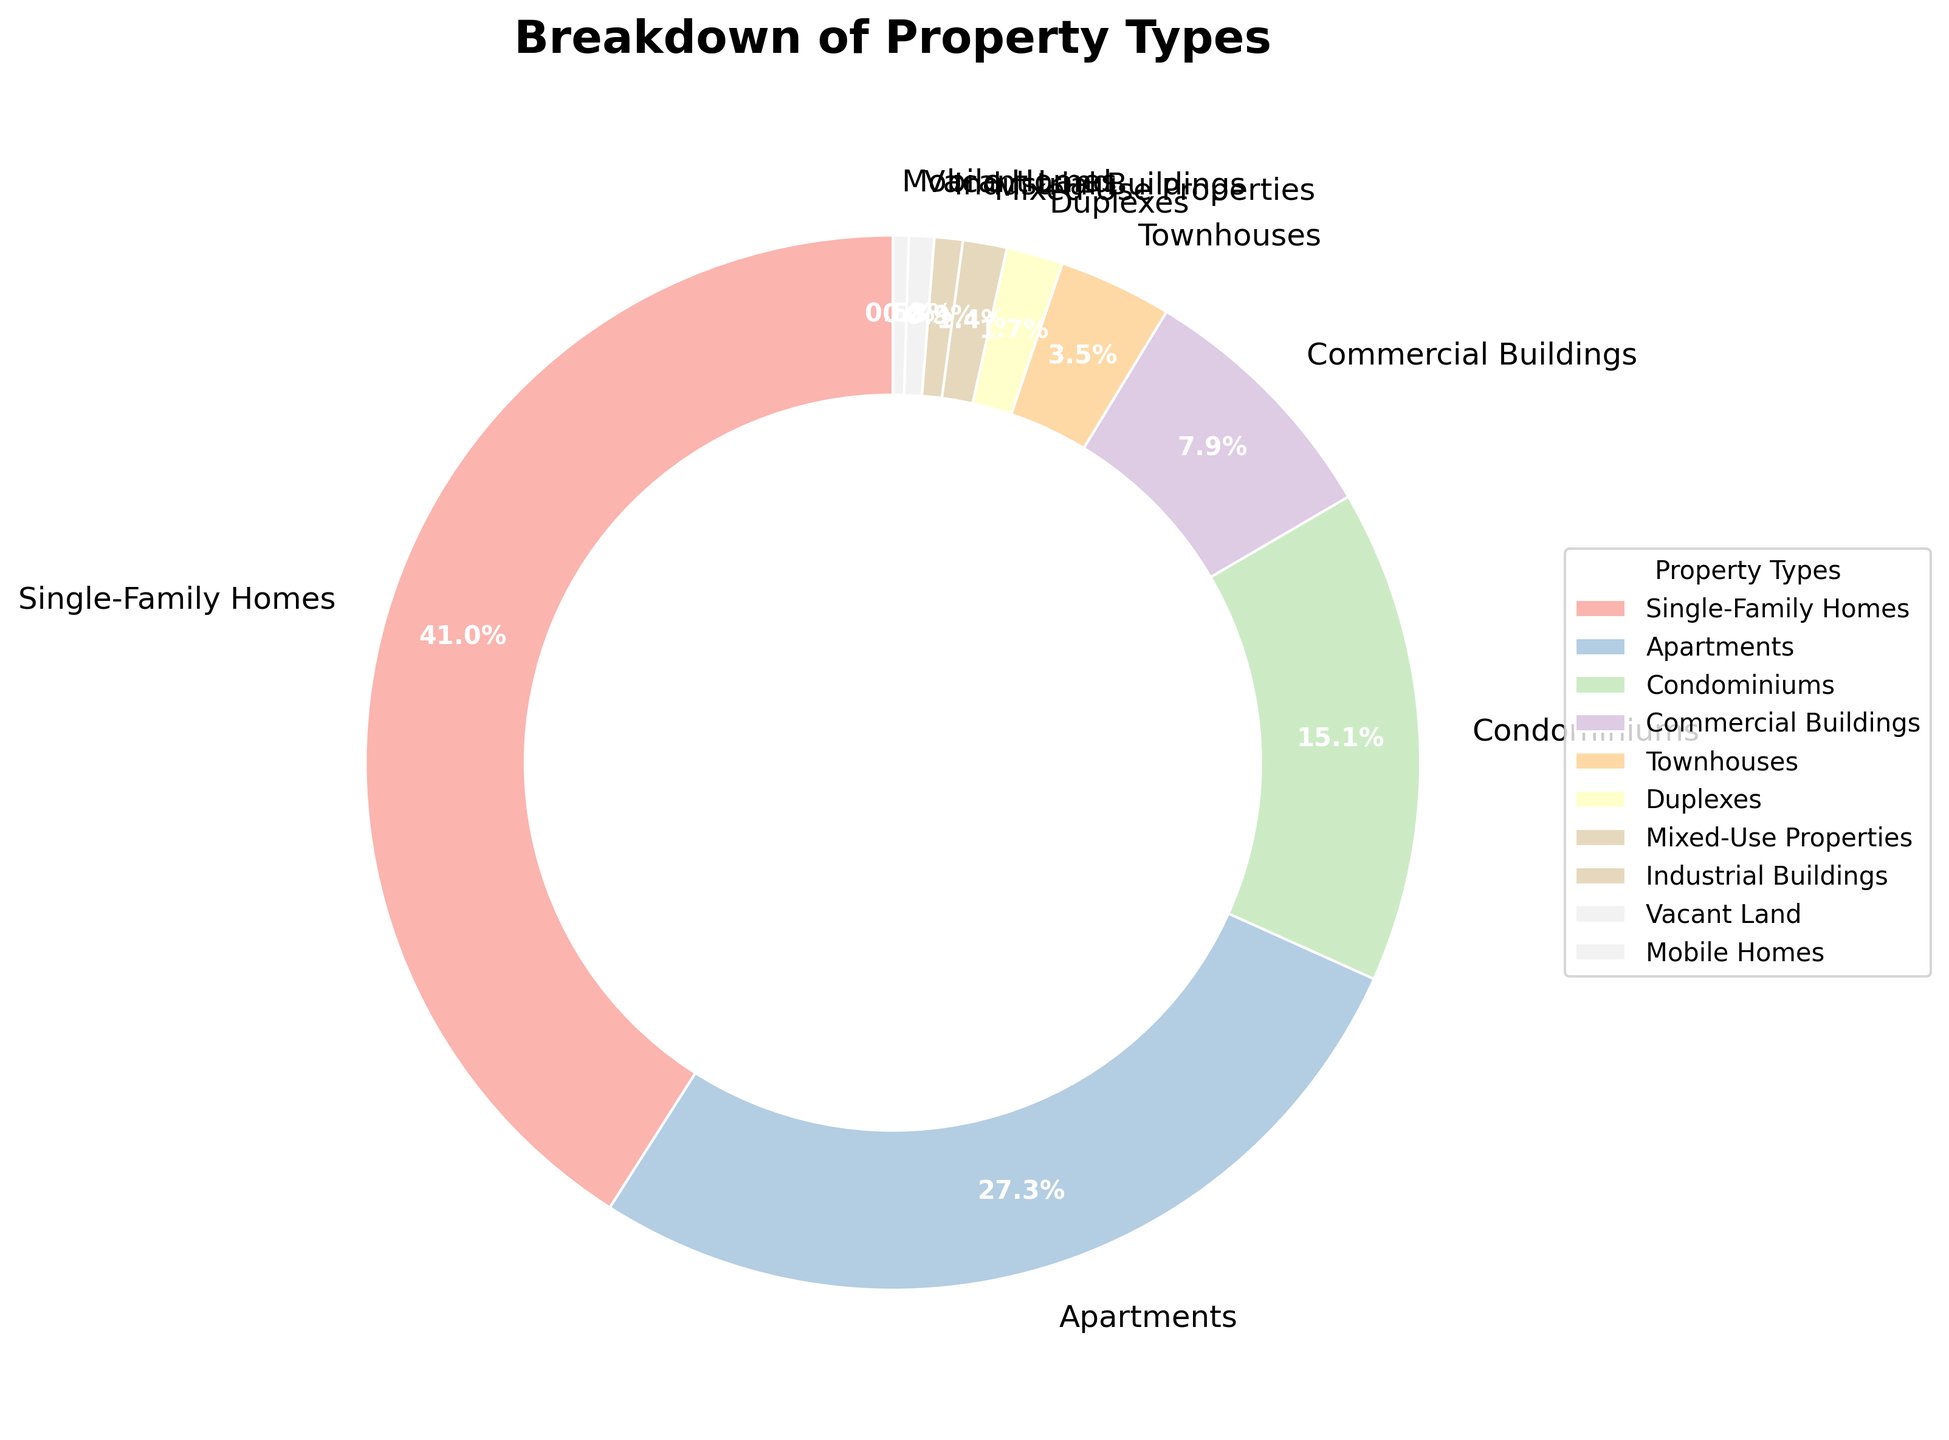What is the most common property type? The largest section of the pie chart represents Single-Family Homes with a percentage of 42.5%.
Answer: Single-Family Homes Which property type has the smallest percentage? The smallest slice of the pie chart corresponds to Mobile Homes, accounting for 0.5%.
Answer: Mobile Homes How much more common are Single-Family Homes compared to Apartments? Single-Family Homes account for 42.5%, and Apartments account for 28.3%. The difference is 42.5% - 28.3% = 14.2%.
Answer: 14.2% What percentage of properties are residential (Single-Family Homes, Apartments, Condominiums, and Townhouses)? Adding the percentages of Single-Family Homes (42.5%), Apartments (28.3%), Condominiums (15.7%), and Townhouses (3.6%) gives 42.5% + 28.3% + 15.7% + 3.6% = 90.1%.
Answer: 90.1% Are there more Condominiums or Commercial Buildings? The pie chart shows that Condominiums account for 15.7% and Commercial Buildings for 8.2%, so there are more Condominiums.
Answer: Condominiums Which category represents less than 1% of the total properties? Examining the pie chart, the slices representing less than 1% are Industrial Buildings (0.9%), Vacant Land (0.8%), Mixed-Use Properties (0.8%), and Mobile Homes (0.5%).
Answer: Industrial Buildings, Vacant Land, Mobile Homes How does the percentage of Townhouses compare to Duplexes? Townhouses make up 3.6% of the properties, while Duplexes make up 1.8%. Townhouses are 3.6% - 1.8% = 1.8% more prevalent than Duplexes.
Answer: 1.8% What is the combined percentage of properties that are not Single-Family Homes, Apartments, or Condominiums? Summing the percentages of properties excluding Single-Family Homes (42.5%), Apartments (28.3%), and Condominiums (15.7%): 100% - (42.5% + 28.3% + 15.7%) = 100% - 86.5% = 13.5%.
Answer: 13.5% Which color represents Industrial Buildings in the pie chart? Examining the pie chart, Industrial Buildings, with 0.9%, are typically assigned a color, often the lighter shade of the palette. The exact color would be one of the light-colored section (refer to the legend for precise match).
Answer: Light-colored section (refer to legend) What is the difference in percentage between Mixed-Use Properties and Vacant Land? Mixed-Use Properties account for 1.4%, and Vacant Land accounts for 0.8%. The difference is 1.4% - 0.8% = 0.6%.
Answer: 0.6% 